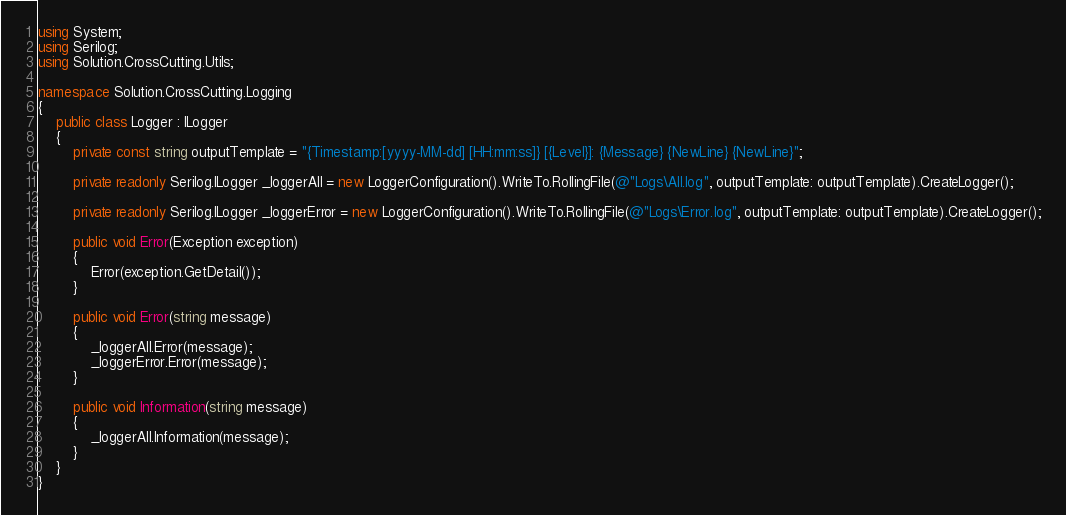Convert code to text. <code><loc_0><loc_0><loc_500><loc_500><_C#_>using System;
using Serilog;
using Solution.CrossCutting.Utils;

namespace Solution.CrossCutting.Logging
{
    public class Logger : ILogger
    {
        private const string outputTemplate = "{Timestamp:[yyyy-MM-dd] [HH:mm:ss]} [{Level}]: {Message} {NewLine} {NewLine}";

        private readonly Serilog.ILogger _loggerAll = new LoggerConfiguration().WriteTo.RollingFile(@"Logs\All.log", outputTemplate: outputTemplate).CreateLogger();

        private readonly Serilog.ILogger _loggerError = new LoggerConfiguration().WriteTo.RollingFile(@"Logs\Error.log", outputTemplate: outputTemplate).CreateLogger();

        public void Error(Exception exception)
        {
            Error(exception.GetDetail());
        }

        public void Error(string message)
        {
            _loggerAll.Error(message);
            _loggerError.Error(message);
        }

        public void Information(string message)
        {
            _loggerAll.Information(message);
        }
    }
}
</code> 